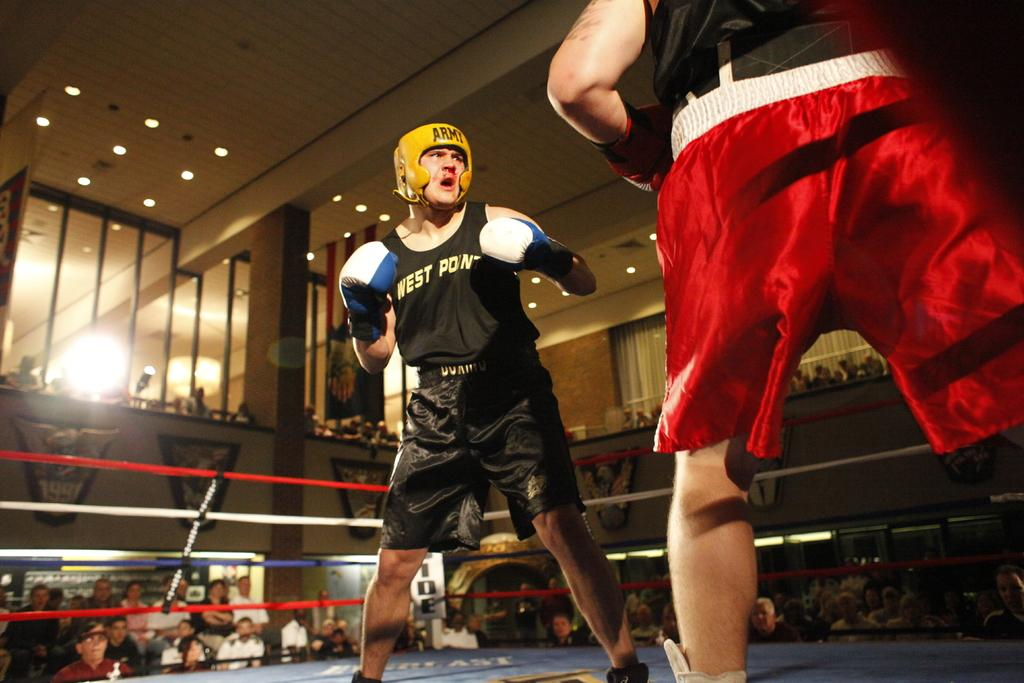What are the two persons in the image doing? The two persons in the image are doing wrestling. Are there any spectators in the image? Yes, a group of people are watching the wrestling game. Where are the spectators located in the image? The group of people is located in the left-hand side bottom of the image. What can be seen in the image that provides lighting? There are ceiling lights visible in the image. What type of hammer is being used by the donkey in the image? There is no donkey or hammer present in the image. Is there a table visible in the image? No, there is no table visible in the image. 